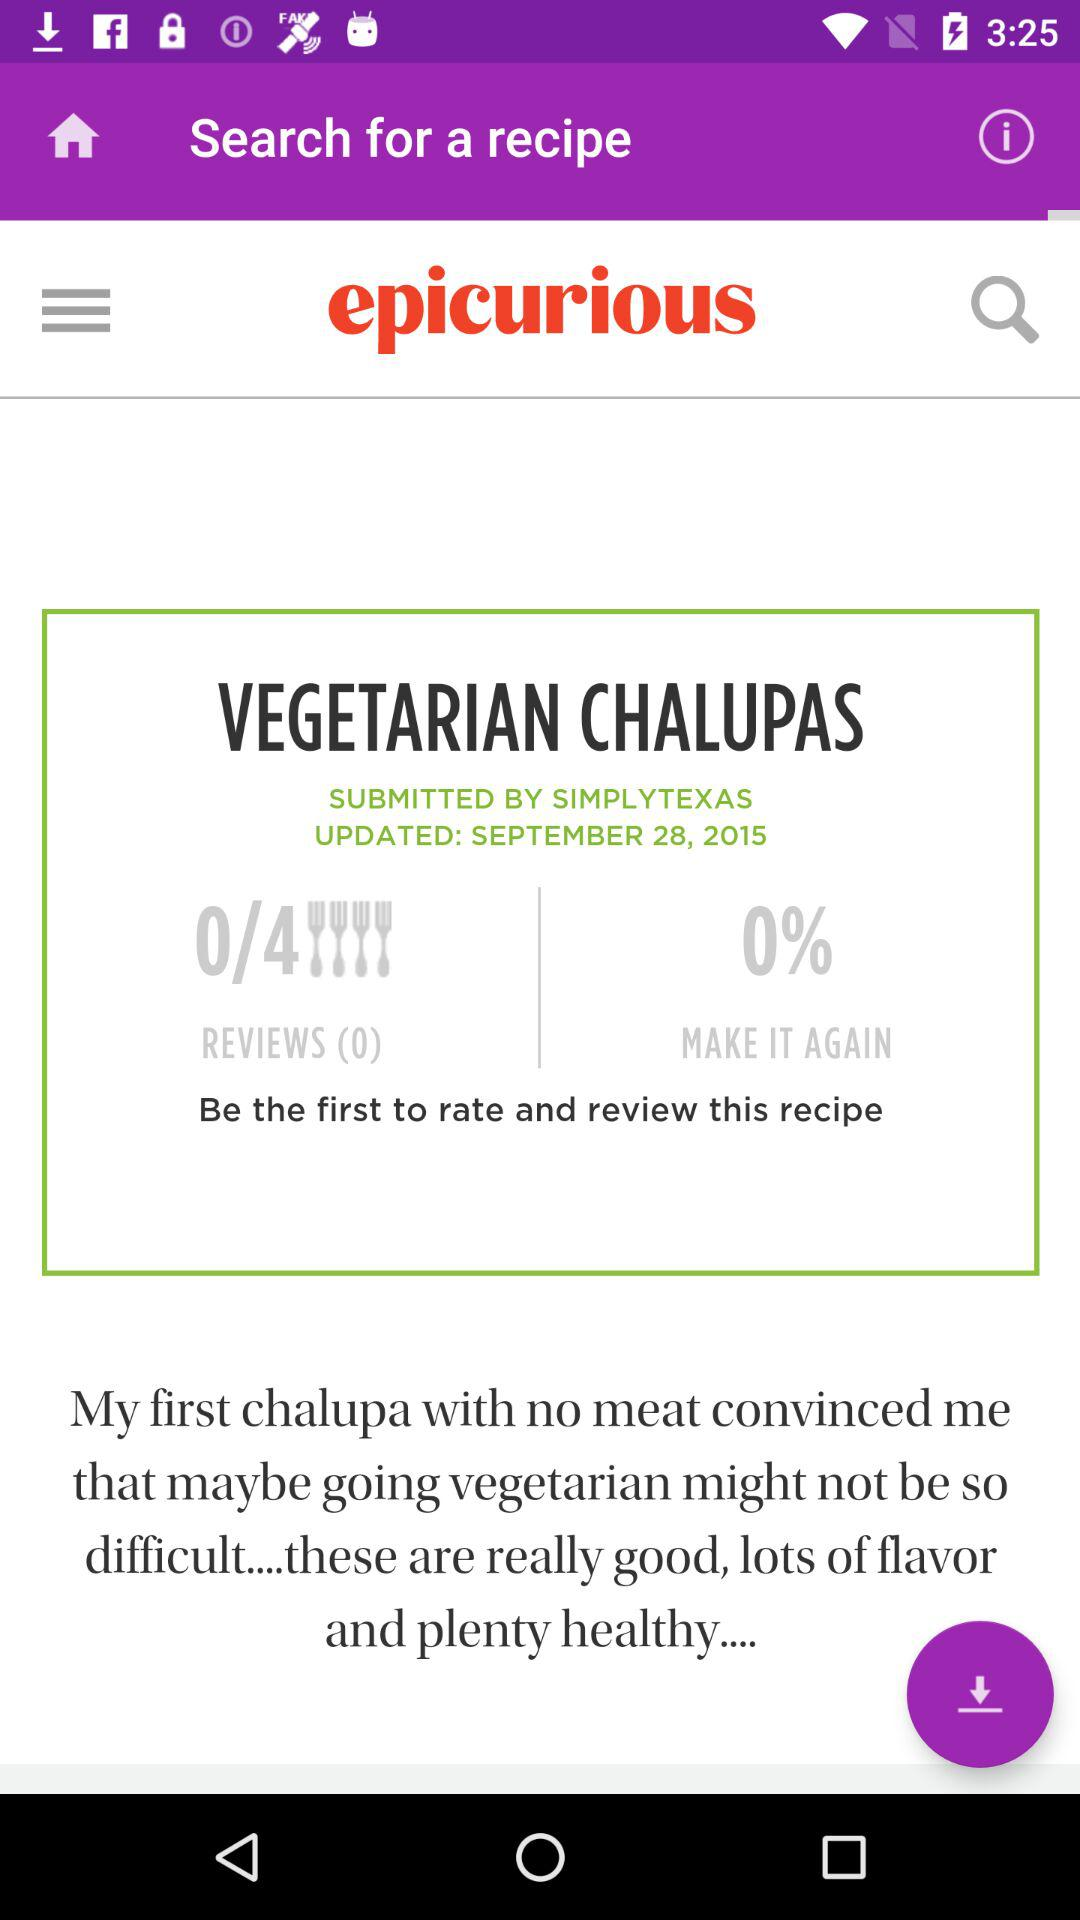How many reviews does this recipe have?
Answer the question using a single word or phrase. 0 